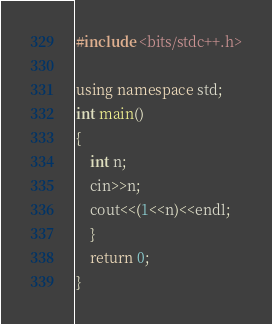<code> <loc_0><loc_0><loc_500><loc_500><_C++_>#include <bits/stdc++.h>

using namespace std;
int main()
{
    int n;
    cin>>n;
    cout<<(1<<n)<<endl;
    }
    return 0;
}
</code> 